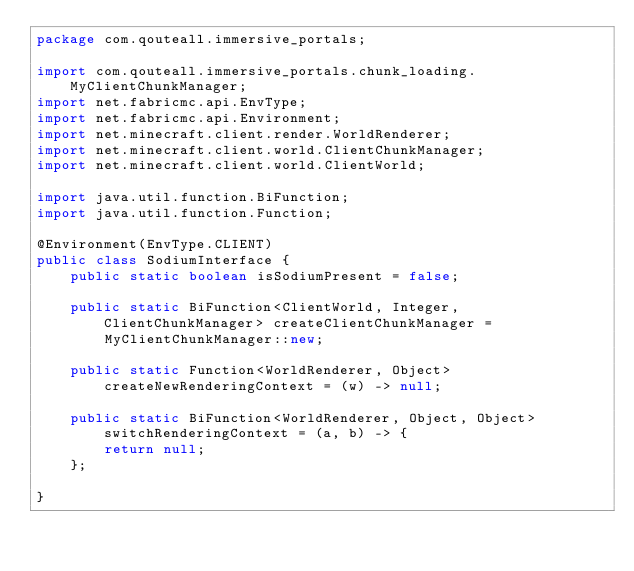Convert code to text. <code><loc_0><loc_0><loc_500><loc_500><_Java_>package com.qouteall.immersive_portals;

import com.qouteall.immersive_portals.chunk_loading.MyClientChunkManager;
import net.fabricmc.api.EnvType;
import net.fabricmc.api.Environment;
import net.minecraft.client.render.WorldRenderer;
import net.minecraft.client.world.ClientChunkManager;
import net.minecraft.client.world.ClientWorld;

import java.util.function.BiFunction;
import java.util.function.Function;

@Environment(EnvType.CLIENT)
public class SodiumInterface {
    public static boolean isSodiumPresent = false;
    
    public static BiFunction<ClientWorld, Integer, ClientChunkManager> createClientChunkManager =
        MyClientChunkManager::new;
    
    public static Function<WorldRenderer, Object> createNewRenderingContext = (w) -> null;
    
    public static BiFunction<WorldRenderer, Object, Object> switchRenderingContext = (a, b) -> {
        return null;
    };
    
}
</code> 